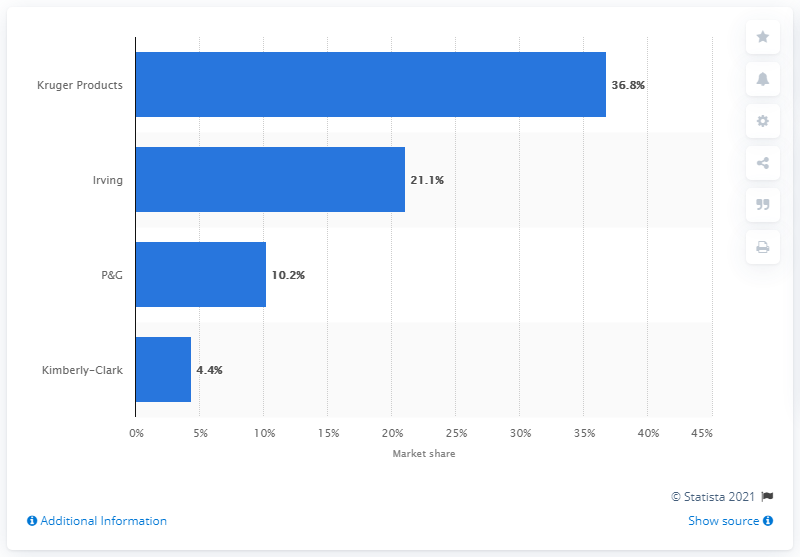Identify some key points in this picture. In September 2016, the market share of P&G bathroom tissues in Canada was 10.2%. 